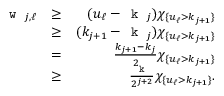<formula> <loc_0><loc_0><loc_500><loc_500>\begin{array} { r l r } { w _ { j , \ell } } & { \geq } & { ( u _ { \ell } - k _ { j } ) \chi _ { \{ u _ { \ell } > k _ { j + 1 } \} } } \\ & { \geq } & { ( k _ { j + 1 } - k _ { j } ) \chi _ { \{ u _ { \ell } > k _ { j + 1 } \} } } \\ & { = } & { \frac { k _ { j + 1 } - k _ { j } } { 2 } \chi _ { \{ u _ { \ell } > k _ { j + 1 } \} } } \\ & { \geq } & { \frac { k } { 2 ^ { j + 2 } } \chi _ { \{ u _ { \ell } > k _ { j + 1 } \} } . } \end{array}</formula> 